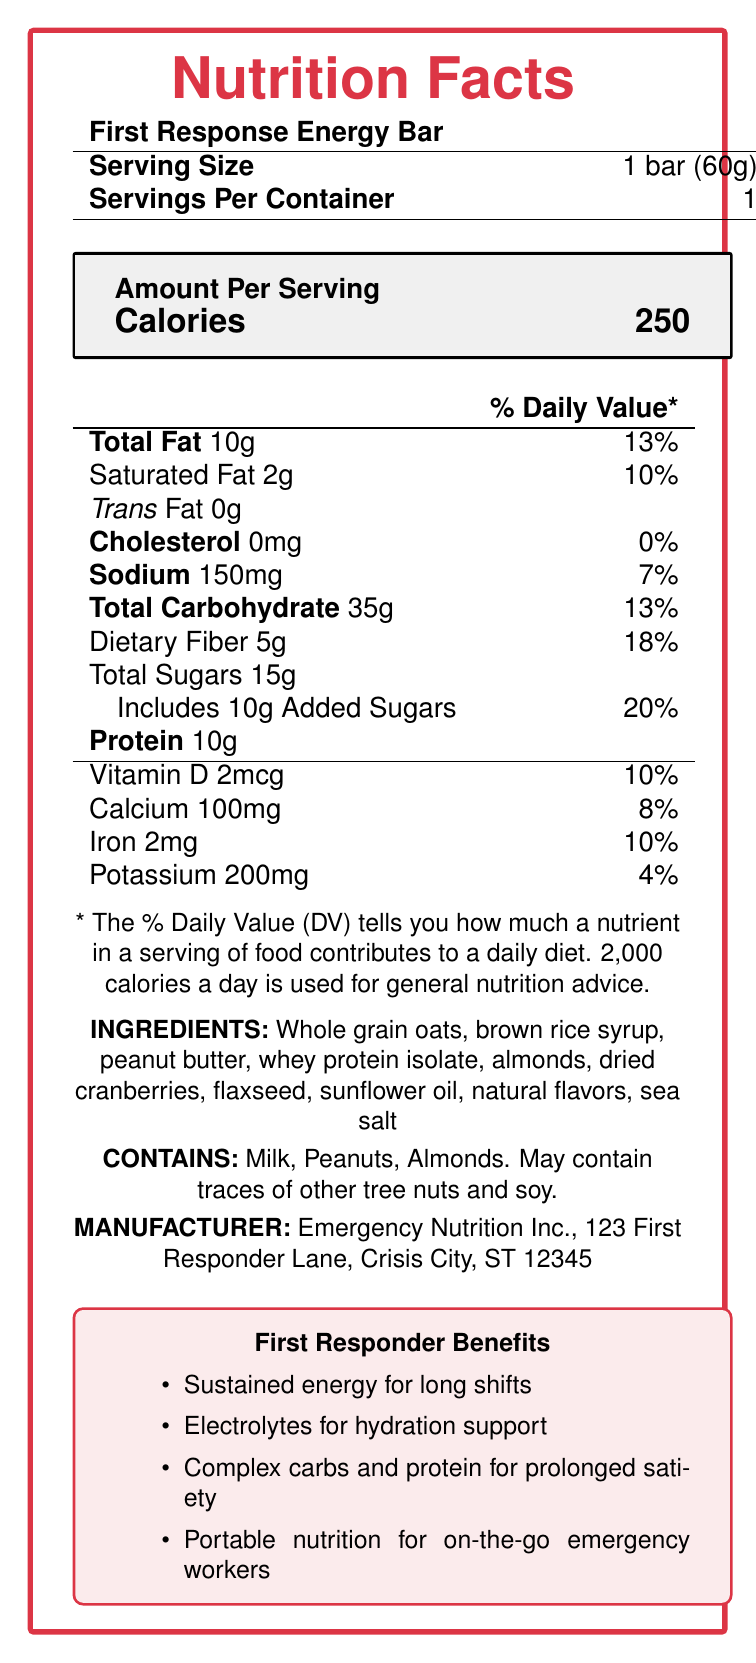what is the serving size for the First Response Energy Bar? The serving size is mentioned as "1 bar (60g)".
Answer: 1 bar (60g) how many calories are there per serving? The document states that each serving contains 250 calories.
Answer: 250 how much total fat is in the energy bar? The total fat content is listed as 10g.
Answer: 10g what percentage of the daily value is the dietary fiber? The document specifies that dietary fiber makes up 18% of the daily value.
Answer: 18% how many grams of added sugars are in the bar? The added sugars are listed separately as 10g.
Answer: 10g Does the energy bar contain any vitamin D? If so, how much? The vitamin section states that the bar contains 2mcg of Vitamin D.
Answer: Yes, 2mcg what are the ingredients in the First Response Energy Bar? The list of ingredients is provided clearly in the document.
Answer: Whole grain oats, brown rice syrup, peanut butter, whey protein isolate, almonds, dried cranberries, flaxseed, sunflower oil, natural flavors, sea salt which allergens are present in the First Response Energy Bar? A. Milk B. Peanuts C. Almonds D. Gluten The document states that the bar contains milk, peanuts, almonds, and may contain traces of other tree nuts and soy but does not mention gluten.
Answer: A, B, C what is the sodium content in the energy bar? The nutrition facts state that the sodium content is 150mg.
Answer: 150mg what are the electrolyte elements mentioned in the document? The document mentions sodium and potassium as electrolytes in the vitamins section.
Answer: Sodium, Potassium Can you find the price of the First Response Energy Bar from the document? The document does not provide any pricing information.
Answer: Cannot be determined Is the First Response Energy Bar marketed as supporting hydration? One of the marketing claims states that the bar contains electrolytes to support hydration.
Answer: Yes Does the energy bar contain artificial flavors? The ingredients list only mentions natural flavors, not artificial ones.
Answer: No What is the main purpose of the First Response Energy Bar? The marketing claims and journalist notes indicate that it is designed for quick and sustained energy suitable for emergency workers.
Answer: To provide quick, sustained energy for first responders who may face long, stressful shifts. Please summarize the information about the First Response Energy Bar. The summary encompasses the serving size, nutritional content, intended benefits, main ingredients, allergen information, and the manufacturer’s identity, providing a comprehensive overview.
Answer: The First Response Energy Bar is a 60g energy bar tailored for first responders and emergency workers, offering 250 calories per serving. It provides a blend of 10g protein, 10g total fat (13% DV), 35g carbohydrates (including 5g dietary fiber and 10g added sugars), and essential vitamins and minerals like Vitamin D, Calcium, Iron, and Potassium. The bar is marketed for sustained energy, hydration support with electrolytes, and prolonged satiety during long shifts. It contains whole grain oats, peanut butter, and dried cranberries, among other ingredients. It contains allergens like milk, peanuts, and almonds and is made by Emergency Nutrition Inc. 